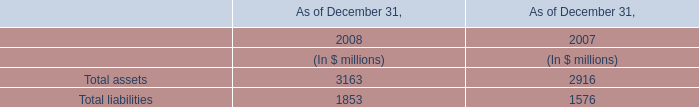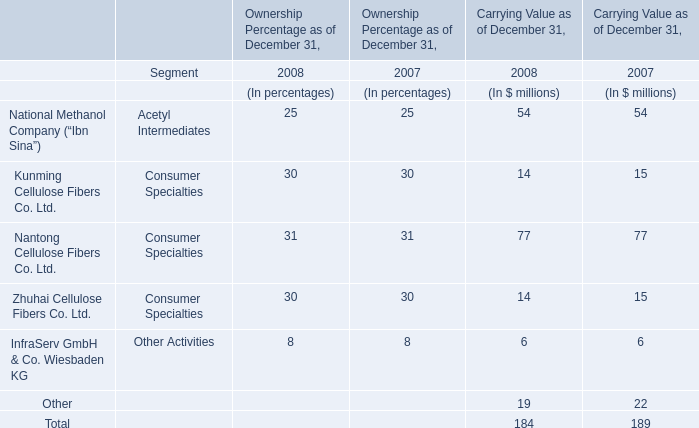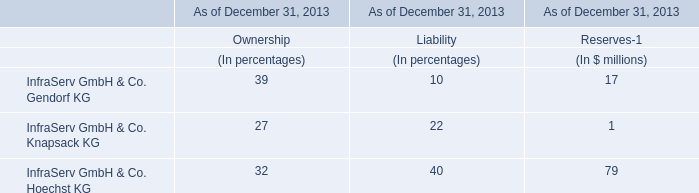What's the current growth rate of Total for Carrying Value as of December 31? 
Computations: ((184 - 189) / 189)
Answer: -0.02646. 